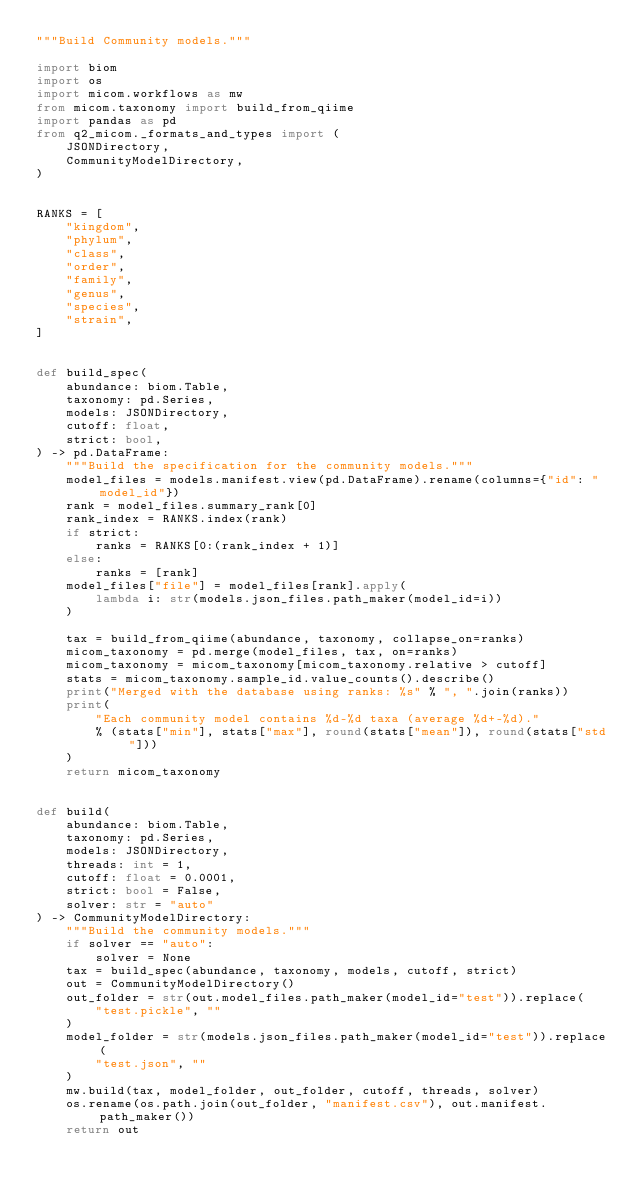Convert code to text. <code><loc_0><loc_0><loc_500><loc_500><_Python_>"""Build Community models."""

import biom
import os
import micom.workflows as mw
from micom.taxonomy import build_from_qiime
import pandas as pd
from q2_micom._formats_and_types import (
    JSONDirectory,
    CommunityModelDirectory,
)


RANKS = [
    "kingdom",
    "phylum",
    "class",
    "order",
    "family",
    "genus",
    "species",
    "strain",
]


def build_spec(
    abundance: biom.Table,
    taxonomy: pd.Series,
    models: JSONDirectory,
    cutoff: float,
    strict: bool,
) -> pd.DataFrame:
    """Build the specification for the community models."""
    model_files = models.manifest.view(pd.DataFrame).rename(columns={"id": "model_id"})
    rank = model_files.summary_rank[0]
    rank_index = RANKS.index(rank)
    if strict:
        ranks = RANKS[0:(rank_index + 1)]
    else:
        ranks = [rank]
    model_files["file"] = model_files[rank].apply(
        lambda i: str(models.json_files.path_maker(model_id=i))
    )

    tax = build_from_qiime(abundance, taxonomy, collapse_on=ranks)
    micom_taxonomy = pd.merge(model_files, tax, on=ranks)
    micom_taxonomy = micom_taxonomy[micom_taxonomy.relative > cutoff]
    stats = micom_taxonomy.sample_id.value_counts().describe()
    print("Merged with the database using ranks: %s" % ", ".join(ranks))
    print(
        "Each community model contains %d-%d taxa (average %d+-%d)."
        % (stats["min"], stats["max"], round(stats["mean"]), round(stats["std"]))
    )
    return micom_taxonomy


def build(
    abundance: biom.Table,
    taxonomy: pd.Series,
    models: JSONDirectory,
    threads: int = 1,
    cutoff: float = 0.0001,
    strict: bool = False,
    solver: str = "auto"
) -> CommunityModelDirectory:
    """Build the community models."""
    if solver == "auto":
        solver = None
    tax = build_spec(abundance, taxonomy, models, cutoff, strict)
    out = CommunityModelDirectory()
    out_folder = str(out.model_files.path_maker(model_id="test")).replace(
        "test.pickle", ""
    )
    model_folder = str(models.json_files.path_maker(model_id="test")).replace(
        "test.json", ""
    )
    mw.build(tax, model_folder, out_folder, cutoff, threads, solver)
    os.rename(os.path.join(out_folder, "manifest.csv"), out.manifest.path_maker())
    return out
</code> 